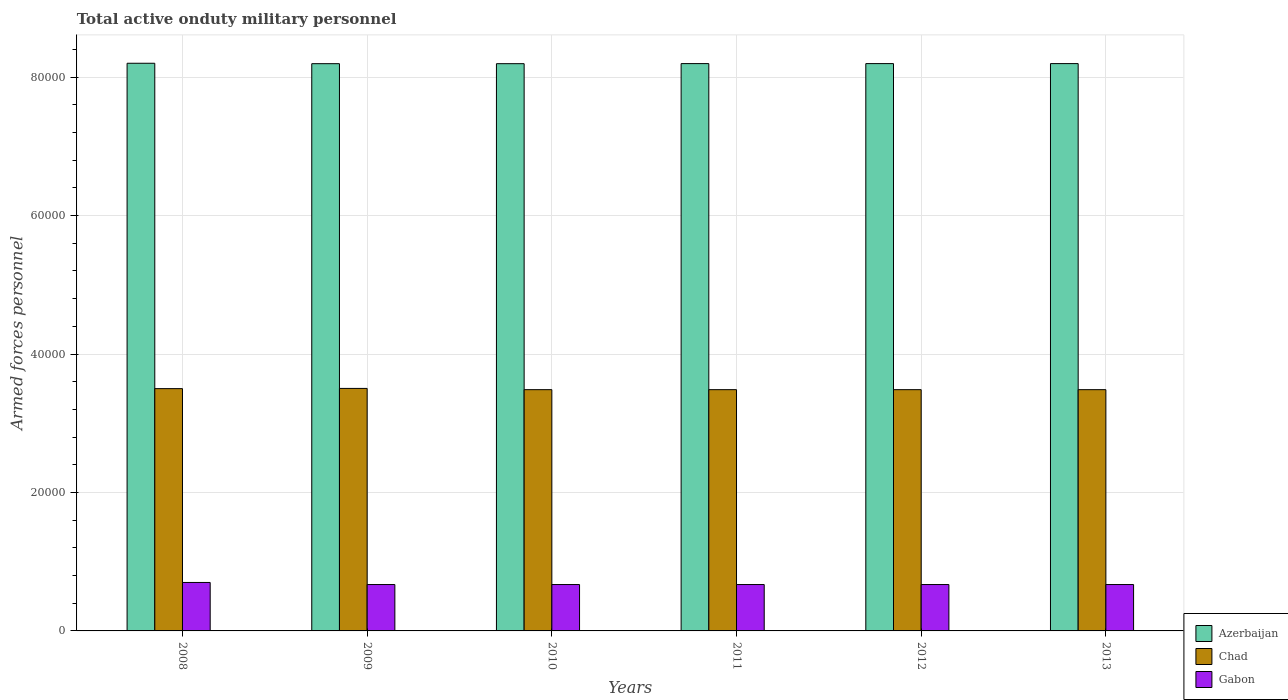How many different coloured bars are there?
Give a very brief answer. 3. How many groups of bars are there?
Your answer should be compact. 6. How many bars are there on the 2nd tick from the left?
Offer a terse response. 3. What is the label of the 2nd group of bars from the left?
Give a very brief answer. 2009. What is the number of armed forces personnel in Chad in 2011?
Your answer should be compact. 3.48e+04. Across all years, what is the maximum number of armed forces personnel in Azerbaijan?
Provide a short and direct response. 8.20e+04. Across all years, what is the minimum number of armed forces personnel in Gabon?
Make the answer very short. 6700. What is the total number of armed forces personnel in Azerbaijan in the graph?
Ensure brevity in your answer.  4.92e+05. What is the difference between the number of armed forces personnel in Azerbaijan in 2010 and the number of armed forces personnel in Chad in 2012?
Give a very brief answer. 4.71e+04. What is the average number of armed forces personnel in Gabon per year?
Ensure brevity in your answer.  6750. In the year 2013, what is the difference between the number of armed forces personnel in Chad and number of armed forces personnel in Azerbaijan?
Provide a succinct answer. -4.71e+04. In how many years, is the number of armed forces personnel in Azerbaijan greater than 40000?
Make the answer very short. 6. What is the ratio of the number of armed forces personnel in Chad in 2008 to that in 2012?
Give a very brief answer. 1. Is the difference between the number of armed forces personnel in Chad in 2008 and 2010 greater than the difference between the number of armed forces personnel in Azerbaijan in 2008 and 2010?
Give a very brief answer. Yes. In how many years, is the number of armed forces personnel in Gabon greater than the average number of armed forces personnel in Gabon taken over all years?
Offer a very short reply. 1. What does the 3rd bar from the left in 2012 represents?
Keep it short and to the point. Gabon. What does the 1st bar from the right in 2008 represents?
Ensure brevity in your answer.  Gabon. Is it the case that in every year, the sum of the number of armed forces personnel in Chad and number of armed forces personnel in Gabon is greater than the number of armed forces personnel in Azerbaijan?
Give a very brief answer. No. How many years are there in the graph?
Ensure brevity in your answer.  6. Are the values on the major ticks of Y-axis written in scientific E-notation?
Offer a very short reply. No. Does the graph contain any zero values?
Offer a terse response. No. Does the graph contain grids?
Offer a very short reply. Yes. How are the legend labels stacked?
Your response must be concise. Vertical. What is the title of the graph?
Your answer should be very brief. Total active onduty military personnel. What is the label or title of the Y-axis?
Make the answer very short. Armed forces personnel. What is the Armed forces personnel of Azerbaijan in 2008?
Ensure brevity in your answer.  8.20e+04. What is the Armed forces personnel of Chad in 2008?
Keep it short and to the point. 3.50e+04. What is the Armed forces personnel of Gabon in 2008?
Your answer should be compact. 7000. What is the Armed forces personnel of Azerbaijan in 2009?
Make the answer very short. 8.19e+04. What is the Armed forces personnel of Chad in 2009?
Keep it short and to the point. 3.50e+04. What is the Armed forces personnel in Gabon in 2009?
Your answer should be very brief. 6700. What is the Armed forces personnel in Azerbaijan in 2010?
Your answer should be very brief. 8.19e+04. What is the Armed forces personnel in Chad in 2010?
Ensure brevity in your answer.  3.48e+04. What is the Armed forces personnel of Gabon in 2010?
Keep it short and to the point. 6700. What is the Armed forces personnel in Azerbaijan in 2011?
Your response must be concise. 8.20e+04. What is the Armed forces personnel in Chad in 2011?
Your answer should be compact. 3.48e+04. What is the Armed forces personnel of Gabon in 2011?
Offer a very short reply. 6700. What is the Armed forces personnel in Azerbaijan in 2012?
Ensure brevity in your answer.  8.20e+04. What is the Armed forces personnel in Chad in 2012?
Give a very brief answer. 3.48e+04. What is the Armed forces personnel of Gabon in 2012?
Ensure brevity in your answer.  6700. What is the Armed forces personnel in Azerbaijan in 2013?
Offer a terse response. 8.20e+04. What is the Armed forces personnel of Chad in 2013?
Give a very brief answer. 3.48e+04. What is the Armed forces personnel of Gabon in 2013?
Give a very brief answer. 6700. Across all years, what is the maximum Armed forces personnel in Azerbaijan?
Give a very brief answer. 8.20e+04. Across all years, what is the maximum Armed forces personnel of Chad?
Keep it short and to the point. 3.50e+04. Across all years, what is the maximum Armed forces personnel of Gabon?
Provide a succinct answer. 7000. Across all years, what is the minimum Armed forces personnel in Azerbaijan?
Keep it short and to the point. 8.19e+04. Across all years, what is the minimum Armed forces personnel of Chad?
Your response must be concise. 3.48e+04. Across all years, what is the minimum Armed forces personnel of Gabon?
Keep it short and to the point. 6700. What is the total Armed forces personnel in Azerbaijan in the graph?
Your response must be concise. 4.92e+05. What is the total Armed forces personnel of Chad in the graph?
Ensure brevity in your answer.  2.09e+05. What is the total Armed forces personnel in Gabon in the graph?
Your response must be concise. 4.05e+04. What is the difference between the Armed forces personnel in Azerbaijan in 2008 and that in 2009?
Provide a short and direct response. 60. What is the difference between the Armed forces personnel in Chad in 2008 and that in 2009?
Make the answer very short. -30. What is the difference between the Armed forces personnel of Gabon in 2008 and that in 2009?
Keep it short and to the point. 300. What is the difference between the Armed forces personnel of Azerbaijan in 2008 and that in 2010?
Keep it short and to the point. 60. What is the difference between the Armed forces personnel in Chad in 2008 and that in 2010?
Ensure brevity in your answer.  150. What is the difference between the Armed forces personnel of Gabon in 2008 and that in 2010?
Give a very brief answer. 300. What is the difference between the Armed forces personnel in Chad in 2008 and that in 2011?
Ensure brevity in your answer.  150. What is the difference between the Armed forces personnel in Gabon in 2008 and that in 2011?
Make the answer very short. 300. What is the difference between the Armed forces personnel of Azerbaijan in 2008 and that in 2012?
Keep it short and to the point. 50. What is the difference between the Armed forces personnel of Chad in 2008 and that in 2012?
Ensure brevity in your answer.  150. What is the difference between the Armed forces personnel in Gabon in 2008 and that in 2012?
Keep it short and to the point. 300. What is the difference between the Armed forces personnel of Azerbaijan in 2008 and that in 2013?
Give a very brief answer. 50. What is the difference between the Armed forces personnel in Chad in 2008 and that in 2013?
Your response must be concise. 150. What is the difference between the Armed forces personnel in Gabon in 2008 and that in 2013?
Keep it short and to the point. 300. What is the difference between the Armed forces personnel of Azerbaijan in 2009 and that in 2010?
Provide a succinct answer. 0. What is the difference between the Armed forces personnel of Chad in 2009 and that in 2010?
Your answer should be very brief. 180. What is the difference between the Armed forces personnel in Gabon in 2009 and that in 2010?
Ensure brevity in your answer.  0. What is the difference between the Armed forces personnel in Chad in 2009 and that in 2011?
Provide a short and direct response. 180. What is the difference between the Armed forces personnel in Gabon in 2009 and that in 2011?
Provide a succinct answer. 0. What is the difference between the Armed forces personnel of Azerbaijan in 2009 and that in 2012?
Your answer should be very brief. -10. What is the difference between the Armed forces personnel in Chad in 2009 and that in 2012?
Make the answer very short. 180. What is the difference between the Armed forces personnel in Chad in 2009 and that in 2013?
Give a very brief answer. 180. What is the difference between the Armed forces personnel of Azerbaijan in 2010 and that in 2011?
Provide a short and direct response. -10. What is the difference between the Armed forces personnel of Chad in 2010 and that in 2011?
Give a very brief answer. 0. What is the difference between the Armed forces personnel of Azerbaijan in 2010 and that in 2012?
Your response must be concise. -10. What is the difference between the Armed forces personnel of Gabon in 2010 and that in 2012?
Your response must be concise. 0. What is the difference between the Armed forces personnel in Chad in 2010 and that in 2013?
Offer a very short reply. 0. What is the difference between the Armed forces personnel in Azerbaijan in 2011 and that in 2012?
Make the answer very short. 0. What is the difference between the Armed forces personnel in Chad in 2011 and that in 2012?
Keep it short and to the point. 0. What is the difference between the Armed forces personnel in Azerbaijan in 2011 and that in 2013?
Give a very brief answer. 0. What is the difference between the Armed forces personnel of Chad in 2011 and that in 2013?
Provide a short and direct response. 0. What is the difference between the Armed forces personnel in Gabon in 2011 and that in 2013?
Give a very brief answer. 0. What is the difference between the Armed forces personnel of Azerbaijan in 2012 and that in 2013?
Provide a succinct answer. 0. What is the difference between the Armed forces personnel of Chad in 2012 and that in 2013?
Provide a short and direct response. 0. What is the difference between the Armed forces personnel in Gabon in 2012 and that in 2013?
Make the answer very short. 0. What is the difference between the Armed forces personnel in Azerbaijan in 2008 and the Armed forces personnel in Chad in 2009?
Keep it short and to the point. 4.70e+04. What is the difference between the Armed forces personnel of Azerbaijan in 2008 and the Armed forces personnel of Gabon in 2009?
Provide a succinct answer. 7.53e+04. What is the difference between the Armed forces personnel of Chad in 2008 and the Armed forces personnel of Gabon in 2009?
Make the answer very short. 2.83e+04. What is the difference between the Armed forces personnel in Azerbaijan in 2008 and the Armed forces personnel in Chad in 2010?
Provide a succinct answer. 4.72e+04. What is the difference between the Armed forces personnel in Azerbaijan in 2008 and the Armed forces personnel in Gabon in 2010?
Keep it short and to the point. 7.53e+04. What is the difference between the Armed forces personnel of Chad in 2008 and the Armed forces personnel of Gabon in 2010?
Ensure brevity in your answer.  2.83e+04. What is the difference between the Armed forces personnel in Azerbaijan in 2008 and the Armed forces personnel in Chad in 2011?
Your response must be concise. 4.72e+04. What is the difference between the Armed forces personnel of Azerbaijan in 2008 and the Armed forces personnel of Gabon in 2011?
Give a very brief answer. 7.53e+04. What is the difference between the Armed forces personnel of Chad in 2008 and the Armed forces personnel of Gabon in 2011?
Provide a succinct answer. 2.83e+04. What is the difference between the Armed forces personnel of Azerbaijan in 2008 and the Armed forces personnel of Chad in 2012?
Keep it short and to the point. 4.72e+04. What is the difference between the Armed forces personnel of Azerbaijan in 2008 and the Armed forces personnel of Gabon in 2012?
Your answer should be very brief. 7.53e+04. What is the difference between the Armed forces personnel in Chad in 2008 and the Armed forces personnel in Gabon in 2012?
Provide a short and direct response. 2.83e+04. What is the difference between the Armed forces personnel in Azerbaijan in 2008 and the Armed forces personnel in Chad in 2013?
Your response must be concise. 4.72e+04. What is the difference between the Armed forces personnel of Azerbaijan in 2008 and the Armed forces personnel of Gabon in 2013?
Provide a short and direct response. 7.53e+04. What is the difference between the Armed forces personnel in Chad in 2008 and the Armed forces personnel in Gabon in 2013?
Make the answer very short. 2.83e+04. What is the difference between the Armed forces personnel of Azerbaijan in 2009 and the Armed forces personnel of Chad in 2010?
Your answer should be compact. 4.71e+04. What is the difference between the Armed forces personnel in Azerbaijan in 2009 and the Armed forces personnel in Gabon in 2010?
Your response must be concise. 7.52e+04. What is the difference between the Armed forces personnel of Chad in 2009 and the Armed forces personnel of Gabon in 2010?
Ensure brevity in your answer.  2.83e+04. What is the difference between the Armed forces personnel in Azerbaijan in 2009 and the Armed forces personnel in Chad in 2011?
Ensure brevity in your answer.  4.71e+04. What is the difference between the Armed forces personnel in Azerbaijan in 2009 and the Armed forces personnel in Gabon in 2011?
Offer a terse response. 7.52e+04. What is the difference between the Armed forces personnel of Chad in 2009 and the Armed forces personnel of Gabon in 2011?
Keep it short and to the point. 2.83e+04. What is the difference between the Armed forces personnel in Azerbaijan in 2009 and the Armed forces personnel in Chad in 2012?
Ensure brevity in your answer.  4.71e+04. What is the difference between the Armed forces personnel in Azerbaijan in 2009 and the Armed forces personnel in Gabon in 2012?
Provide a succinct answer. 7.52e+04. What is the difference between the Armed forces personnel of Chad in 2009 and the Armed forces personnel of Gabon in 2012?
Keep it short and to the point. 2.83e+04. What is the difference between the Armed forces personnel in Azerbaijan in 2009 and the Armed forces personnel in Chad in 2013?
Offer a very short reply. 4.71e+04. What is the difference between the Armed forces personnel of Azerbaijan in 2009 and the Armed forces personnel of Gabon in 2013?
Your answer should be compact. 7.52e+04. What is the difference between the Armed forces personnel in Chad in 2009 and the Armed forces personnel in Gabon in 2013?
Provide a short and direct response. 2.83e+04. What is the difference between the Armed forces personnel in Azerbaijan in 2010 and the Armed forces personnel in Chad in 2011?
Provide a succinct answer. 4.71e+04. What is the difference between the Armed forces personnel of Azerbaijan in 2010 and the Armed forces personnel of Gabon in 2011?
Offer a terse response. 7.52e+04. What is the difference between the Armed forces personnel of Chad in 2010 and the Armed forces personnel of Gabon in 2011?
Your answer should be compact. 2.82e+04. What is the difference between the Armed forces personnel in Azerbaijan in 2010 and the Armed forces personnel in Chad in 2012?
Make the answer very short. 4.71e+04. What is the difference between the Armed forces personnel in Azerbaijan in 2010 and the Armed forces personnel in Gabon in 2012?
Keep it short and to the point. 7.52e+04. What is the difference between the Armed forces personnel in Chad in 2010 and the Armed forces personnel in Gabon in 2012?
Your answer should be very brief. 2.82e+04. What is the difference between the Armed forces personnel in Azerbaijan in 2010 and the Armed forces personnel in Chad in 2013?
Make the answer very short. 4.71e+04. What is the difference between the Armed forces personnel in Azerbaijan in 2010 and the Armed forces personnel in Gabon in 2013?
Your answer should be compact. 7.52e+04. What is the difference between the Armed forces personnel of Chad in 2010 and the Armed forces personnel of Gabon in 2013?
Give a very brief answer. 2.82e+04. What is the difference between the Armed forces personnel of Azerbaijan in 2011 and the Armed forces personnel of Chad in 2012?
Give a very brief answer. 4.71e+04. What is the difference between the Armed forces personnel of Azerbaijan in 2011 and the Armed forces personnel of Gabon in 2012?
Keep it short and to the point. 7.52e+04. What is the difference between the Armed forces personnel in Chad in 2011 and the Armed forces personnel in Gabon in 2012?
Give a very brief answer. 2.82e+04. What is the difference between the Armed forces personnel of Azerbaijan in 2011 and the Armed forces personnel of Chad in 2013?
Offer a very short reply. 4.71e+04. What is the difference between the Armed forces personnel in Azerbaijan in 2011 and the Armed forces personnel in Gabon in 2013?
Give a very brief answer. 7.52e+04. What is the difference between the Armed forces personnel of Chad in 2011 and the Armed forces personnel of Gabon in 2013?
Give a very brief answer. 2.82e+04. What is the difference between the Armed forces personnel of Azerbaijan in 2012 and the Armed forces personnel of Chad in 2013?
Your answer should be compact. 4.71e+04. What is the difference between the Armed forces personnel in Azerbaijan in 2012 and the Armed forces personnel in Gabon in 2013?
Ensure brevity in your answer.  7.52e+04. What is the difference between the Armed forces personnel in Chad in 2012 and the Armed forces personnel in Gabon in 2013?
Your answer should be very brief. 2.82e+04. What is the average Armed forces personnel of Azerbaijan per year?
Your answer should be compact. 8.20e+04. What is the average Armed forces personnel of Chad per year?
Keep it short and to the point. 3.49e+04. What is the average Armed forces personnel of Gabon per year?
Offer a terse response. 6750. In the year 2008, what is the difference between the Armed forces personnel in Azerbaijan and Armed forces personnel in Chad?
Provide a short and direct response. 4.70e+04. In the year 2008, what is the difference between the Armed forces personnel of Azerbaijan and Armed forces personnel of Gabon?
Your answer should be very brief. 7.50e+04. In the year 2008, what is the difference between the Armed forces personnel of Chad and Armed forces personnel of Gabon?
Give a very brief answer. 2.80e+04. In the year 2009, what is the difference between the Armed forces personnel in Azerbaijan and Armed forces personnel in Chad?
Your response must be concise. 4.69e+04. In the year 2009, what is the difference between the Armed forces personnel of Azerbaijan and Armed forces personnel of Gabon?
Provide a succinct answer. 7.52e+04. In the year 2009, what is the difference between the Armed forces personnel in Chad and Armed forces personnel in Gabon?
Give a very brief answer. 2.83e+04. In the year 2010, what is the difference between the Armed forces personnel in Azerbaijan and Armed forces personnel in Chad?
Your answer should be compact. 4.71e+04. In the year 2010, what is the difference between the Armed forces personnel in Azerbaijan and Armed forces personnel in Gabon?
Give a very brief answer. 7.52e+04. In the year 2010, what is the difference between the Armed forces personnel of Chad and Armed forces personnel of Gabon?
Your answer should be very brief. 2.82e+04. In the year 2011, what is the difference between the Armed forces personnel of Azerbaijan and Armed forces personnel of Chad?
Your answer should be very brief. 4.71e+04. In the year 2011, what is the difference between the Armed forces personnel of Azerbaijan and Armed forces personnel of Gabon?
Make the answer very short. 7.52e+04. In the year 2011, what is the difference between the Armed forces personnel in Chad and Armed forces personnel in Gabon?
Give a very brief answer. 2.82e+04. In the year 2012, what is the difference between the Armed forces personnel in Azerbaijan and Armed forces personnel in Chad?
Provide a short and direct response. 4.71e+04. In the year 2012, what is the difference between the Armed forces personnel in Azerbaijan and Armed forces personnel in Gabon?
Provide a short and direct response. 7.52e+04. In the year 2012, what is the difference between the Armed forces personnel of Chad and Armed forces personnel of Gabon?
Make the answer very short. 2.82e+04. In the year 2013, what is the difference between the Armed forces personnel of Azerbaijan and Armed forces personnel of Chad?
Your response must be concise. 4.71e+04. In the year 2013, what is the difference between the Armed forces personnel in Azerbaijan and Armed forces personnel in Gabon?
Offer a very short reply. 7.52e+04. In the year 2013, what is the difference between the Armed forces personnel of Chad and Armed forces personnel of Gabon?
Keep it short and to the point. 2.82e+04. What is the ratio of the Armed forces personnel in Gabon in 2008 to that in 2009?
Your answer should be compact. 1.04. What is the ratio of the Armed forces personnel in Gabon in 2008 to that in 2010?
Offer a very short reply. 1.04. What is the ratio of the Armed forces personnel of Azerbaijan in 2008 to that in 2011?
Your answer should be very brief. 1. What is the ratio of the Armed forces personnel in Gabon in 2008 to that in 2011?
Provide a short and direct response. 1.04. What is the ratio of the Armed forces personnel in Azerbaijan in 2008 to that in 2012?
Your answer should be very brief. 1. What is the ratio of the Armed forces personnel of Chad in 2008 to that in 2012?
Offer a terse response. 1. What is the ratio of the Armed forces personnel of Gabon in 2008 to that in 2012?
Ensure brevity in your answer.  1.04. What is the ratio of the Armed forces personnel in Azerbaijan in 2008 to that in 2013?
Keep it short and to the point. 1. What is the ratio of the Armed forces personnel of Chad in 2008 to that in 2013?
Your answer should be very brief. 1. What is the ratio of the Armed forces personnel of Gabon in 2008 to that in 2013?
Give a very brief answer. 1.04. What is the ratio of the Armed forces personnel in Azerbaijan in 2009 to that in 2010?
Your answer should be compact. 1. What is the ratio of the Armed forces personnel of Chad in 2009 to that in 2010?
Keep it short and to the point. 1.01. What is the ratio of the Armed forces personnel of Chad in 2009 to that in 2012?
Provide a succinct answer. 1.01. What is the ratio of the Armed forces personnel in Gabon in 2009 to that in 2012?
Your response must be concise. 1. What is the ratio of the Armed forces personnel in Chad in 2009 to that in 2013?
Offer a very short reply. 1.01. What is the ratio of the Armed forces personnel in Gabon in 2009 to that in 2013?
Keep it short and to the point. 1. What is the ratio of the Armed forces personnel in Gabon in 2010 to that in 2011?
Give a very brief answer. 1. What is the ratio of the Armed forces personnel of Azerbaijan in 2010 to that in 2012?
Your response must be concise. 1. What is the ratio of the Armed forces personnel of Chad in 2010 to that in 2012?
Your response must be concise. 1. What is the ratio of the Armed forces personnel in Gabon in 2010 to that in 2012?
Keep it short and to the point. 1. What is the ratio of the Armed forces personnel of Chad in 2010 to that in 2013?
Your answer should be compact. 1. What is the ratio of the Armed forces personnel in Gabon in 2010 to that in 2013?
Provide a succinct answer. 1. What is the ratio of the Armed forces personnel of Azerbaijan in 2011 to that in 2013?
Keep it short and to the point. 1. What is the ratio of the Armed forces personnel in Azerbaijan in 2012 to that in 2013?
Provide a succinct answer. 1. What is the difference between the highest and the second highest Armed forces personnel of Gabon?
Make the answer very short. 300. What is the difference between the highest and the lowest Armed forces personnel of Chad?
Ensure brevity in your answer.  180. What is the difference between the highest and the lowest Armed forces personnel in Gabon?
Offer a very short reply. 300. 